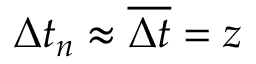Convert formula to latex. <formula><loc_0><loc_0><loc_500><loc_500>\Delta t _ { n } \approx \overline { \Delta t } = z</formula> 